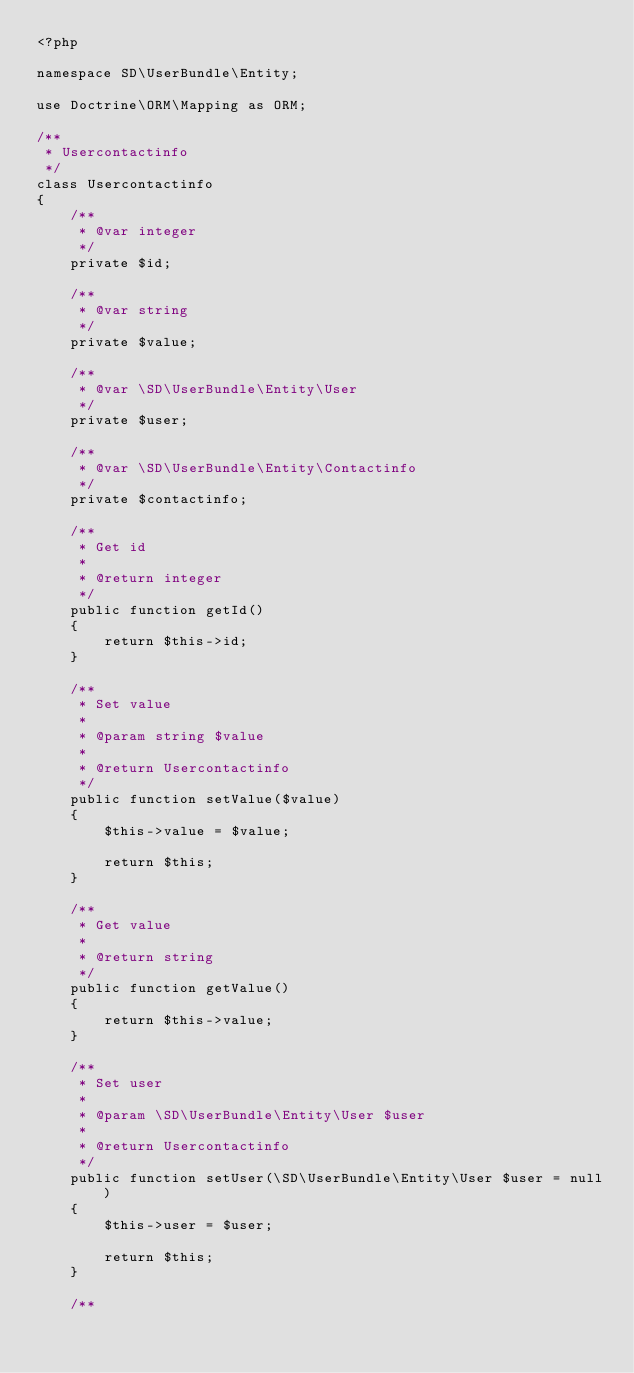<code> <loc_0><loc_0><loc_500><loc_500><_PHP_><?php

namespace SD\UserBundle\Entity;

use Doctrine\ORM\Mapping as ORM;

/**
 * Usercontactinfo
 */
class Usercontactinfo
{
    /**
     * @var integer
     */
    private $id;

    /**
     * @var string
     */
    private $value;

    /**
     * @var \SD\UserBundle\Entity\User
     */
    private $user;

    /**
     * @var \SD\UserBundle\Entity\Contactinfo
     */
    private $contactinfo;

    /**
     * Get id
     *
     * @return integer 
     */
    public function getId()
    {
        return $this->id;
    }

    /**
     * Set value
     *
     * @param string $value
     * 
     * @return Usercontactinfo
     */
    public function setValue($value)
    {
        $this->value = $value;

        return $this;
    }

    /**
     * Get value
     *
     * @return string 
     */
    public function getValue()
    {
        return $this->value;
    }

    /**
     * Set user
     *
     * @param \SD\UserBundle\Entity\User $user
     * 
     * @return Usercontactinfo
     */
    public function setUser(\SD\UserBundle\Entity\User $user = null)
    {
        $this->user = $user;

        return $this;
    }

    /**</code> 